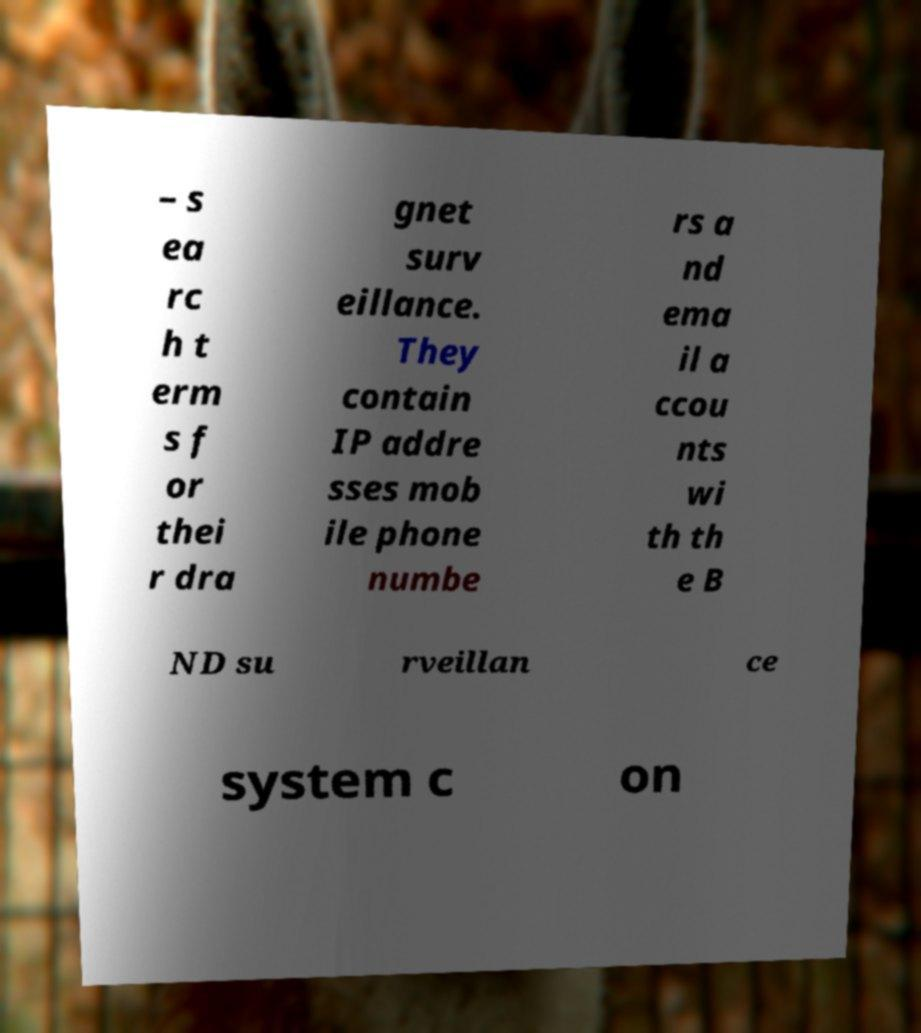Could you extract and type out the text from this image? – s ea rc h t erm s f or thei r dra gnet surv eillance. They contain IP addre sses mob ile phone numbe rs a nd ema il a ccou nts wi th th e B ND su rveillan ce system c on 